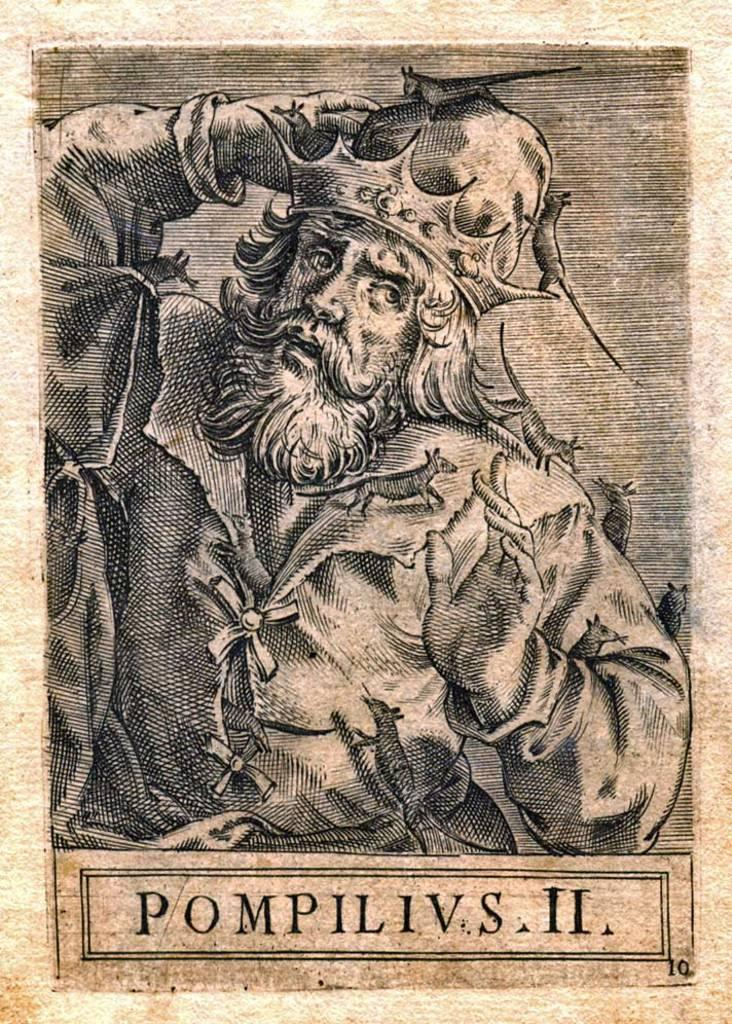What is present in the image? There is a poster in the image. Can you describe the poster? The poster has text at the bottom. What color is the circle on the poster? There is no circle present on the poster in the image. 